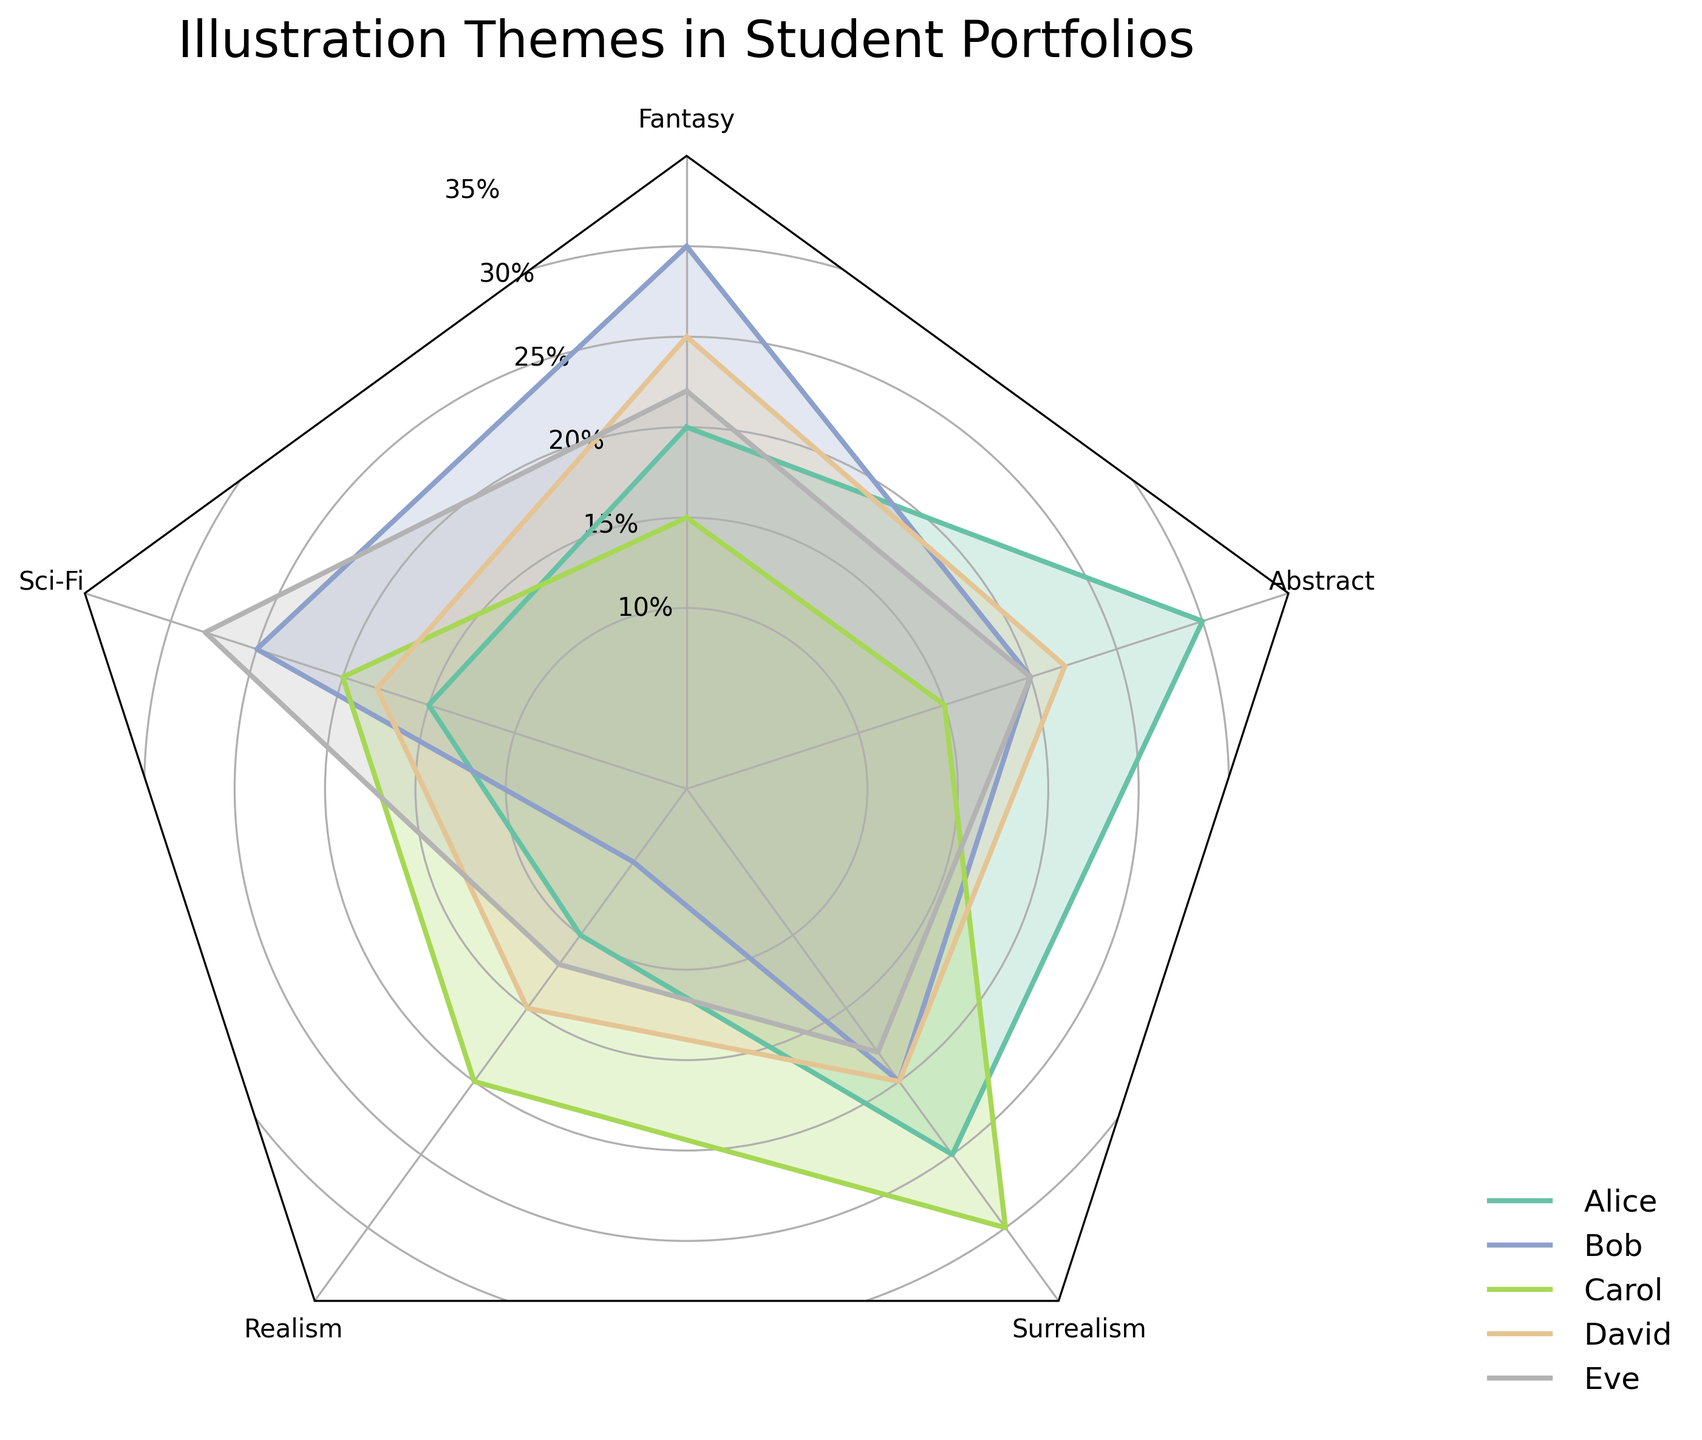How many students are represented in the radar chart? There are five names (Alice, Bob, Carol, David, Eve) listed around the radar chart, each represented by a different color.
Answer: 5 Which illustration theme is most prominent in Alice's portfolio? In Alice's plot, the highest value is 30, which corresponds to the Abstract theme.
Answer: Abstract What is the median frequency of realism in all student portfolios? The realism values for all students are 10, 5, 20, 15, and 12. Sorting these values (5, 10, 12, 15, 20), the median is the middle value.
Answer: 12 Who has the highest frequency of Sci-Fi and what is the value? Looking at the Sci-Fi axis, the highest value is at 28, which belongs to Eve.
Answer: Eve, 28 What's the average frequency of Fantasy in the portfolios? The Fantasy values are 20, 30, 15, 25, and 22. Adding these yields 112, and dividing by 5 gives the average: 112/5 = 22.4
Answer: 22.4 Which theme is least common in Carol’s portfolio? The lowest value in Carol’s segment is for Abstract (value 15).
Answer: Abstract Compare Bob's and David’s illustrations. For which themes does Bob have higher frequencies than David? Bob has higher values in three themes: Fantasy (30 vs. 25), Sci-Fi (25 vs. 18), and Abstract (20 vs. 22). For Abstract, David has the higher value.
Answer: Fantasy, Sci-Fi What is the combined frequency of Surrealism and Realism in David’s portfolio? David has 20 for Surrealism and 15 for Realism. Their combined frequency is 20 + 15 = 35.
Answer: 35 